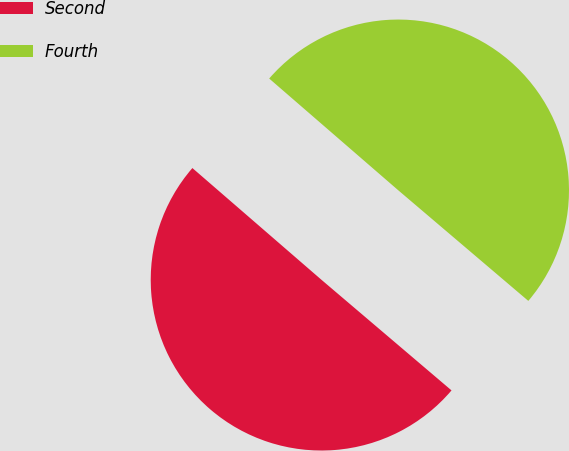<chart> <loc_0><loc_0><loc_500><loc_500><pie_chart><fcel>Second<fcel>Fourth<nl><fcel>50.14%<fcel>49.86%<nl></chart> 